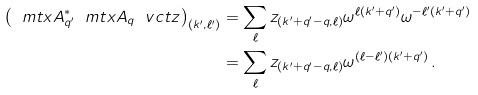<formula> <loc_0><loc_0><loc_500><loc_500>\left ( \ m t x { A } _ { q ^ { \prime } } ^ { \ast } \ m t x { A } _ { q } \ v c t { z } \right ) _ { ( k ^ { \prime } , \ell ^ { \prime } ) } & = \sum _ { \ell } z _ { ( k ^ { \prime } + q ^ { \prime } - q , \ell ) } \omega ^ { \ell ( k ^ { \prime } + q ^ { \prime } ) } \omega ^ { - \ell ^ { \prime } ( k ^ { \prime } + q ^ { \prime } ) } \\ & = \sum _ { \ell } z _ { ( k ^ { \prime } + q ^ { \prime } - q , \ell ) } \omega ^ { ( \ell - \ell ^ { \prime } ) ( k ^ { \prime } + q ^ { \prime } ) } \, .</formula> 